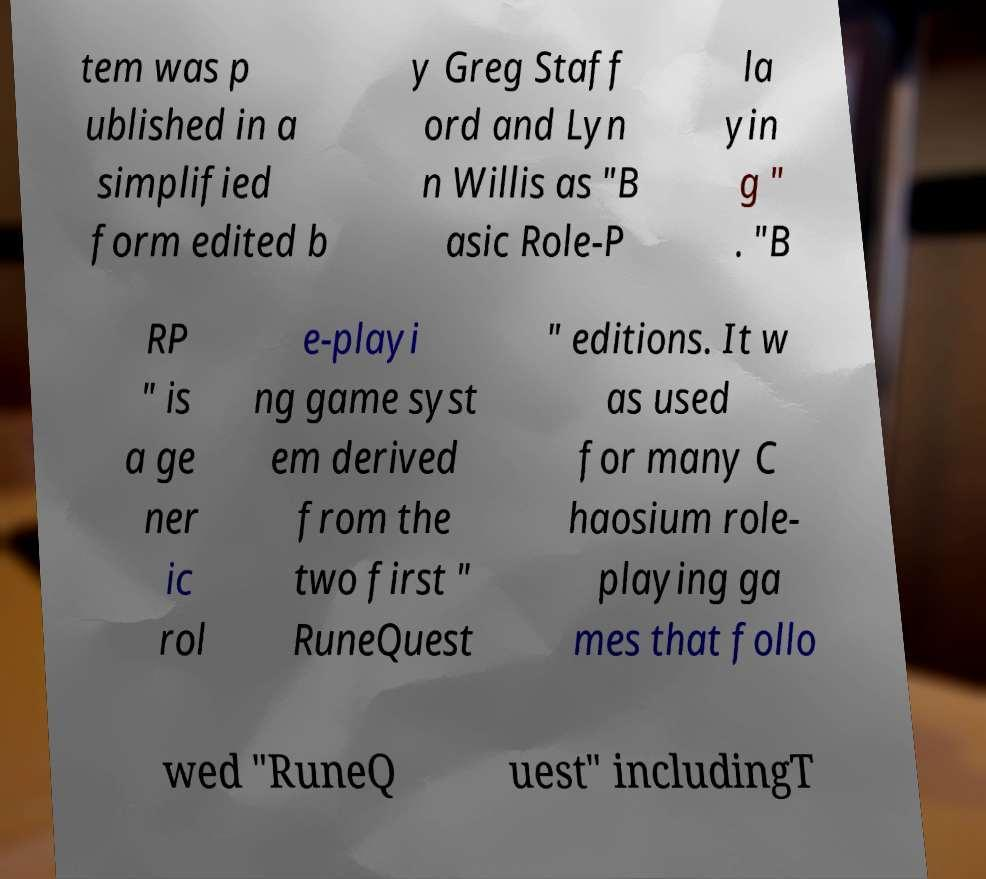Please read and relay the text visible in this image. What does it say? tem was p ublished in a simplified form edited b y Greg Staff ord and Lyn n Willis as "B asic Role-P la yin g " . "B RP " is a ge ner ic rol e-playi ng game syst em derived from the two first " RuneQuest " editions. It w as used for many C haosium role- playing ga mes that follo wed "RuneQ uest" includingT 